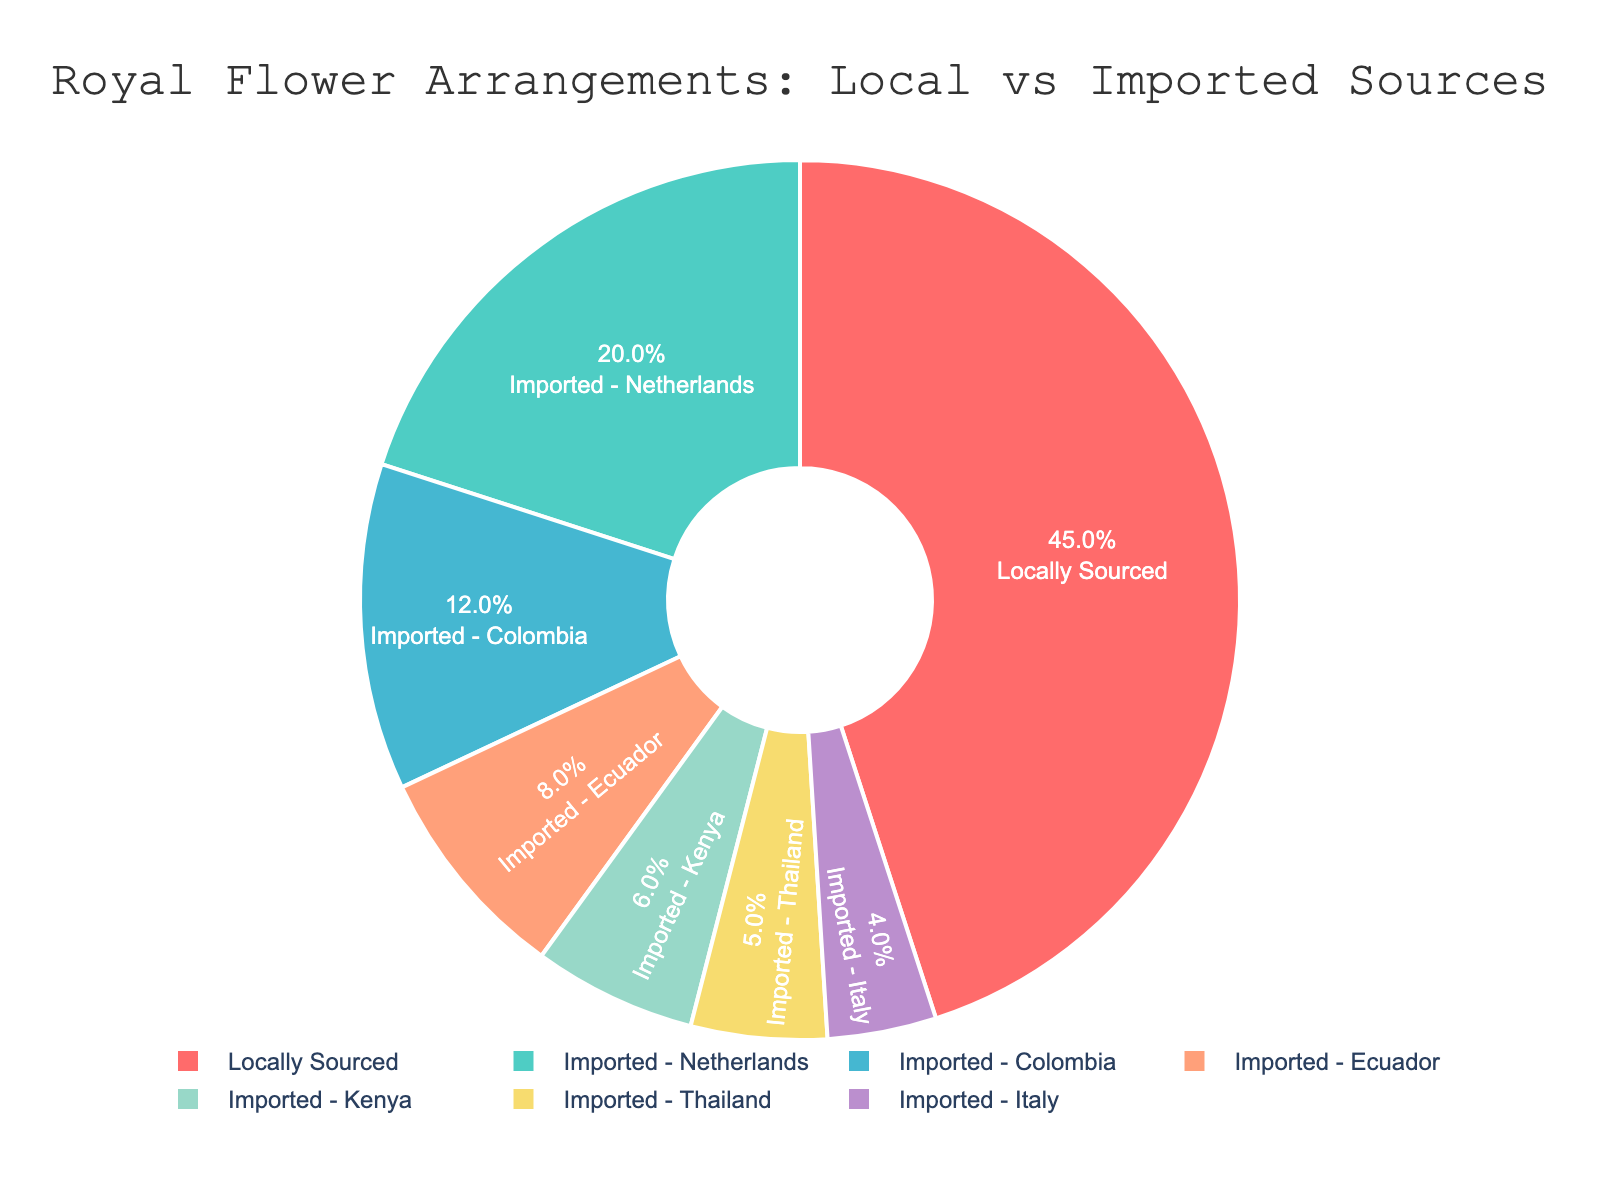What percentage of flowers are locally sourced? The pie chart indicates that 45% of the flowers are locally sourced. The percentage is displayed inside the segment labeled "Locally Sourced."
Answer: 45% Which country is the biggest exporter of flowers to the royal palace? By examining the pie chart, it is clear that the Netherlands is the biggest exporter, as it has the largest slice among the imported sources, occupying 20% of the total.
Answer: Netherlands What is the cumulative percentage of flowers imported from Colombia and Ecuador? To find the cumulative percentage, add the percentages of flowers imported from Colombia (12%) and Ecuador (8%). Therefore, 12% + 8% = 20%.
Answer: 20% How does the proportion of flowers imported from Kenya compare to those imported from Thailand? The slice representing Kenya occupies 6% of the pie, while the slice for Thailand occupies 5%. Therefore, Kenya has a slightly higher proportion of imported flowers compared to Thailand.
Answer: Kenya is higher Which imported source has the smallest proportion of flowers? The smallest slice on the pie chart belongs to Italy, which occupies 4% of the total.
Answer: Italy What is the total percentage of flowers imported from the top three sources? The top three imported sources are the Netherlands (20%), Colombia (12%), and Ecuador (8%). Adding these together gives 20% + 12% + 8% = 40%.
Answer: 40% What fraction of the flowers are imported? Adding the percentages of all imported sources: Netherlands (20%), Colombia (12%), Ecuador (8%), Kenya (6%), Thailand (5%), and Italy (4%) results in 20% + 12% + 8% + 6% + 5% + 4% = 55%. Therefore, 55% of the flowers are imported.
Answer: 55% How does the proportion of imported flowers compare to locally sourced flowers? Locally sourced flowers account for 45%, while imported flowers collectively add up to 55%. Therefore, there are more imported flowers than locally sourced ones.
Answer: Imported > Locally Sourced If the proportion of flowers imported from Ecuador were doubled, what would the new percentage be? Doubling the percentage of flowers imported from Ecuador means multiplying 8% by 2, resulting in 16%.
Answer: 16% Which color represents the locally sourced flowers? The pie slice for locally sourced flowers is colored red. This is identified by matching the label "Locally Sourced" with its corresponding colored segment.
Answer: Red 